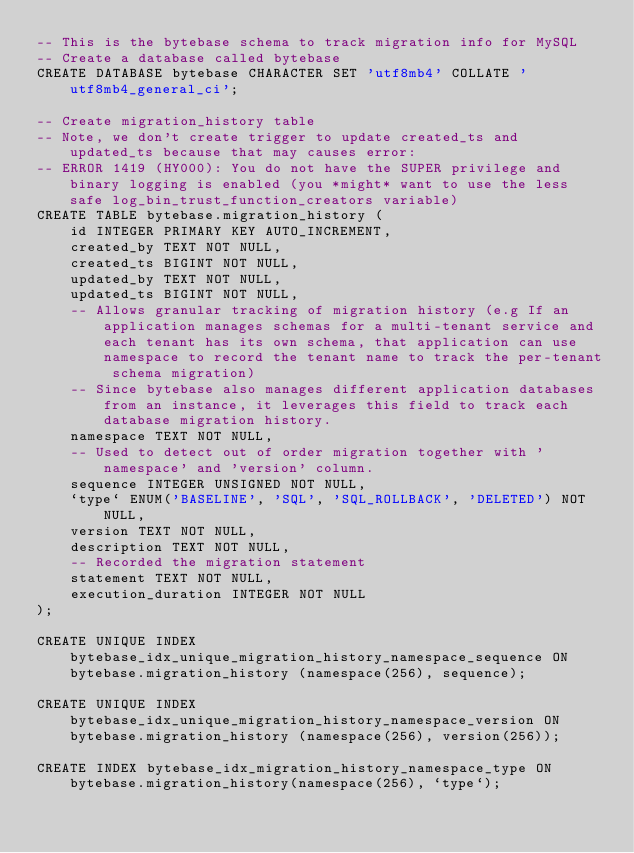Convert code to text. <code><loc_0><loc_0><loc_500><loc_500><_SQL_>-- This is the bytebase schema to track migration info for MySQL
-- Create a database called bytebase
CREATE DATABASE bytebase CHARACTER SET 'utf8mb4' COLLATE 'utf8mb4_general_ci';

-- Create migration_history table
-- Note, we don't create trigger to update created_ts and updated_ts because that may causes error:
-- ERROR 1419 (HY000): You do not have the SUPER privilege and binary logging is enabled (you *might* want to use the less safe log_bin_trust_function_creators variable)
CREATE TABLE bytebase.migration_history (
    id INTEGER PRIMARY KEY AUTO_INCREMENT,
    created_by TEXT NOT NULL,
    created_ts BIGINT NOT NULL,
    updated_by TEXT NOT NULL,
    updated_ts BIGINT NOT NULL,
    -- Allows granular tracking of migration history (e.g If an application manages schemas for a multi-tenant service and each tenant has its own schema, that application can use namespace to record the tenant name to track the per-tenant schema migration)
    -- Since bytebase also manages different application databases from an instance, it leverages this field to track each database migration history.
    namespace TEXT NOT NULL,
    -- Used to detect out of order migration together with 'namespace' and 'version' column.
    sequence INTEGER UNSIGNED NOT NULL,
    `type` ENUM('BASELINE', 'SQL', 'SQL_ROLLBACK', 'DELETED') NOT NULL,
    version TEXT NOT NULL,
    description TEXT NOT NULL,
    -- Recorded the migration statement
    statement TEXT NOT NULL,
    execution_duration INTEGER NOT NULL
);

CREATE UNIQUE INDEX bytebase_idx_unique_migration_history_namespace_sequence ON bytebase.migration_history (namespace(256), sequence);

CREATE UNIQUE INDEX bytebase_idx_unique_migration_history_namespace_version ON bytebase.migration_history (namespace(256), version(256));

CREATE INDEX bytebase_idx_migration_history_namespace_type ON bytebase.migration_history(namespace(256), `type`);</code> 